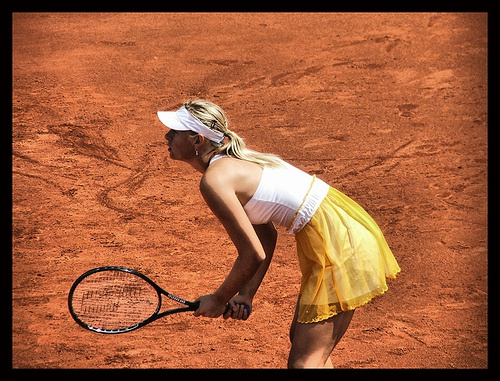Describe the objects in this image and their specific colors. I can see people in black, maroon, white, khaki, and tan tones and tennis racket in black, salmon, and brown tones in this image. 